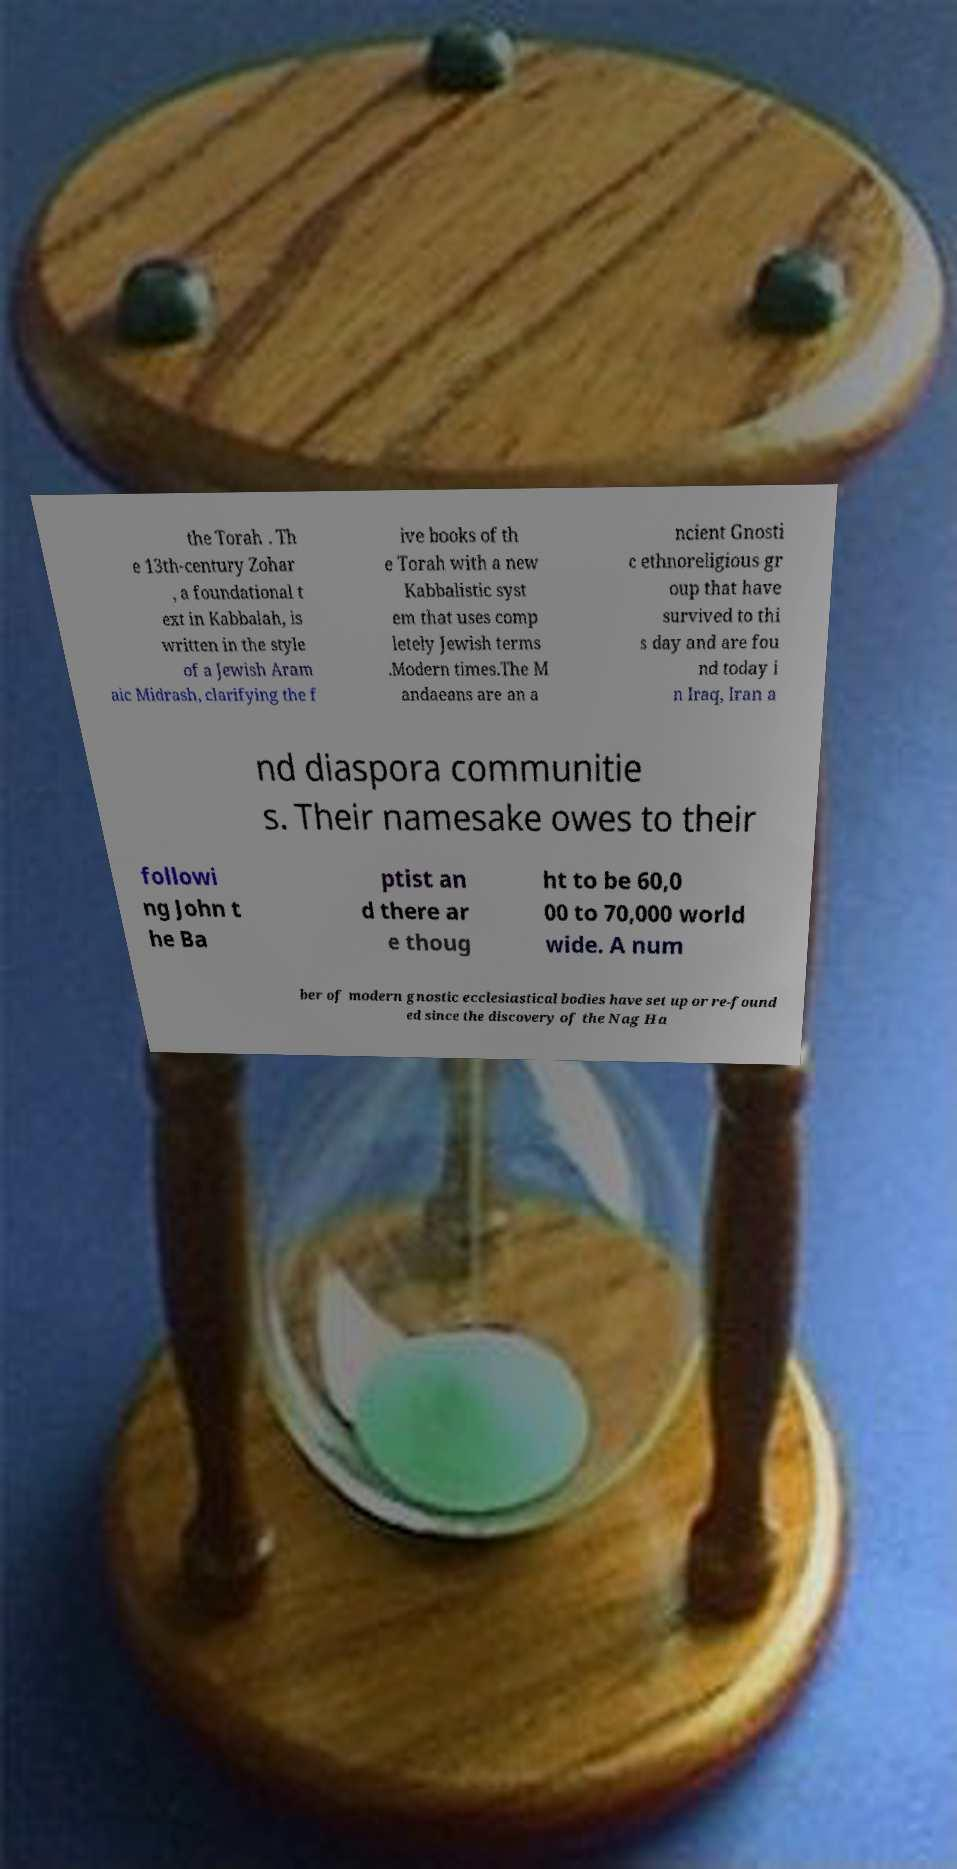I need the written content from this picture converted into text. Can you do that? the Torah . Th e 13th-century Zohar , a foundational t ext in Kabbalah, is written in the style of a Jewish Aram aic Midrash, clarifying the f ive books of th e Torah with a new Kabbalistic syst em that uses comp letely Jewish terms .Modern times.The M andaeans are an a ncient Gnosti c ethnoreligious gr oup that have survived to thi s day and are fou nd today i n Iraq, Iran a nd diaspora communitie s. Their namesake owes to their followi ng John t he Ba ptist an d there ar e thoug ht to be 60,0 00 to 70,000 world wide. A num ber of modern gnostic ecclesiastical bodies have set up or re-found ed since the discovery of the Nag Ha 